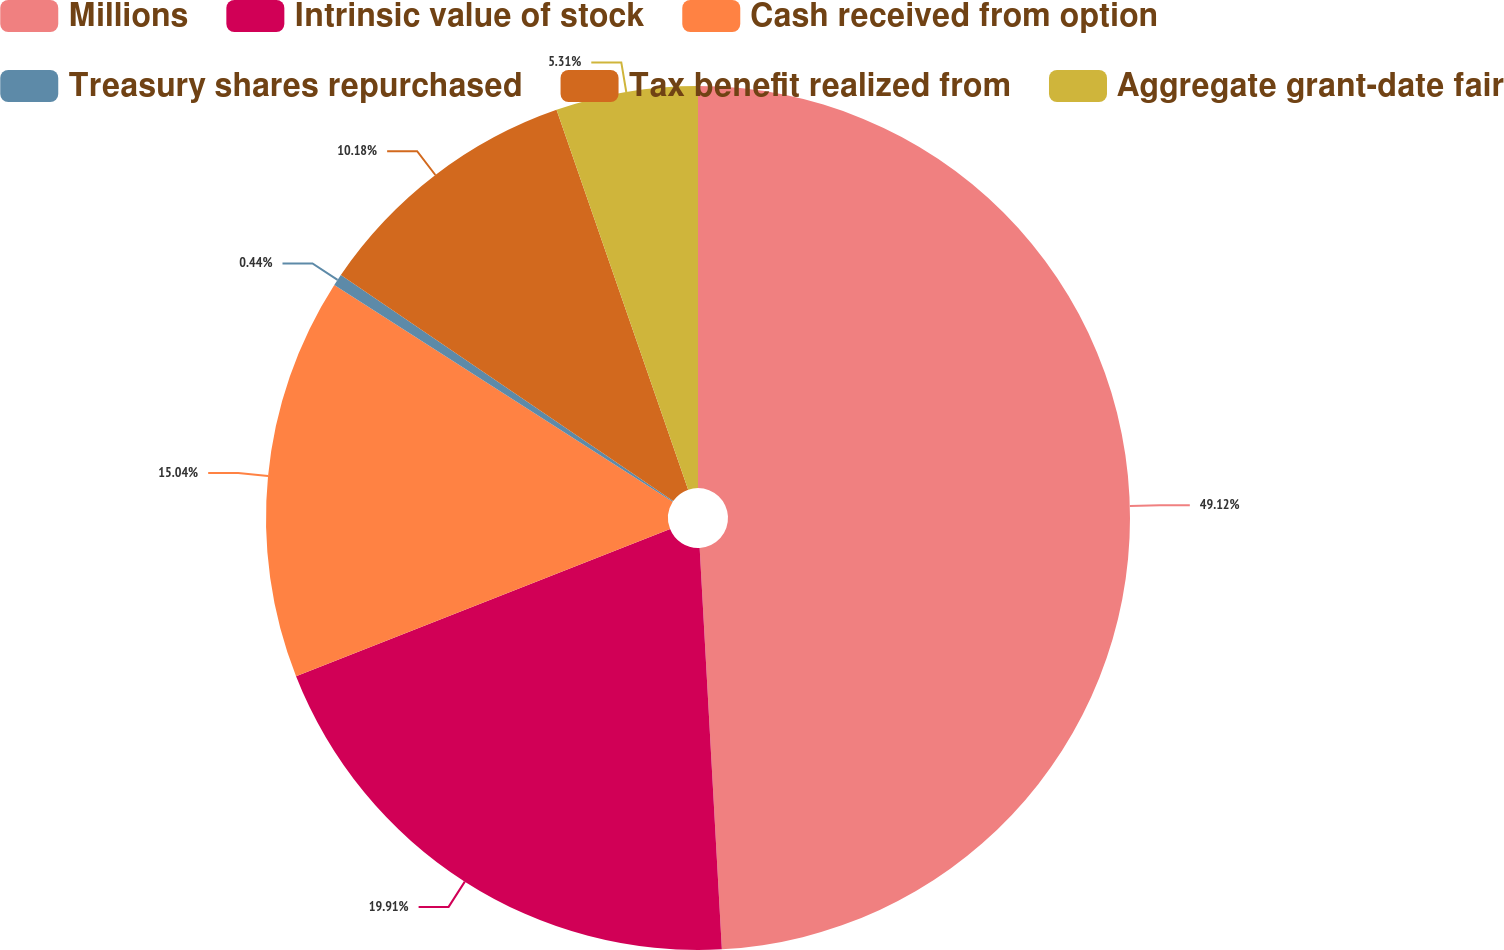<chart> <loc_0><loc_0><loc_500><loc_500><pie_chart><fcel>Millions<fcel>Intrinsic value of stock<fcel>Cash received from option<fcel>Treasury shares repurchased<fcel>Tax benefit realized from<fcel>Aggregate grant-date fair<nl><fcel>49.12%<fcel>19.91%<fcel>15.04%<fcel>0.44%<fcel>10.18%<fcel>5.31%<nl></chart> 